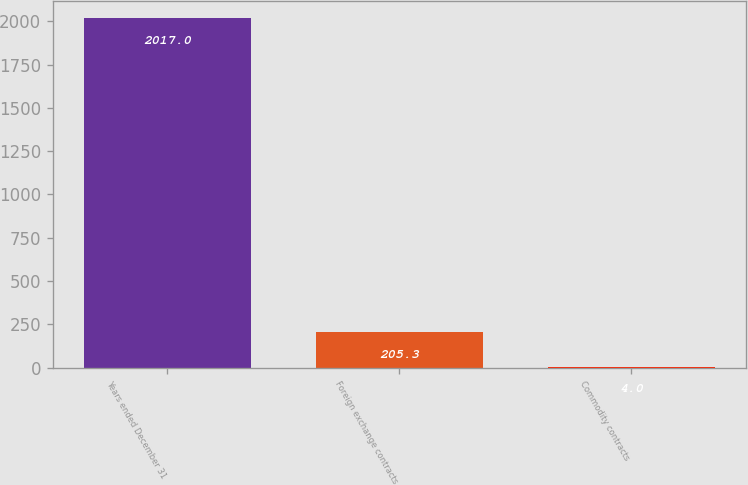Convert chart to OTSL. <chart><loc_0><loc_0><loc_500><loc_500><bar_chart><fcel>Years ended December 31<fcel>Foreign exchange contracts<fcel>Commodity contracts<nl><fcel>2017<fcel>205.3<fcel>4<nl></chart> 